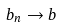<formula> <loc_0><loc_0><loc_500><loc_500>b _ { n } \to b</formula> 